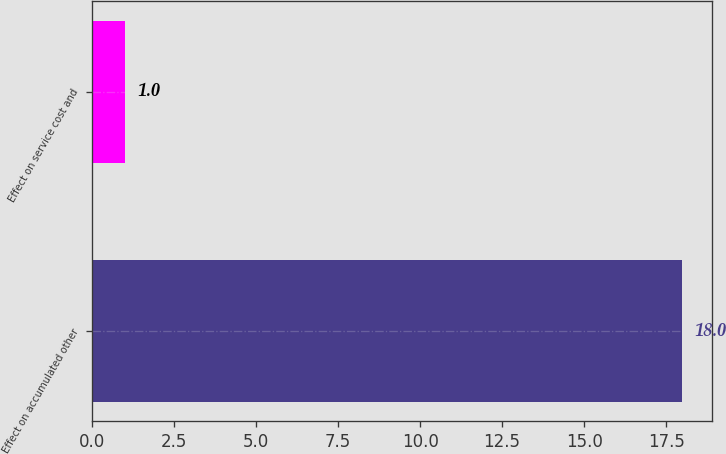Convert chart. <chart><loc_0><loc_0><loc_500><loc_500><bar_chart><fcel>Effect on accumulated other<fcel>Effect on service cost and<nl><fcel>18<fcel>1<nl></chart> 